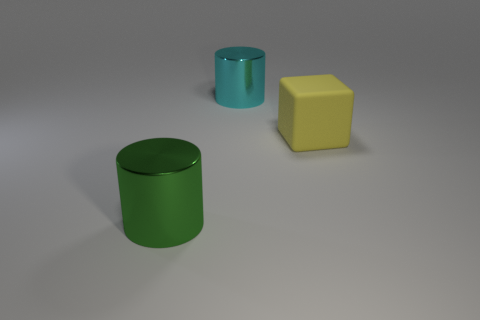There is a large metallic thing that is behind the large yellow matte block; does it have the same shape as the object that is in front of the rubber cube?
Your response must be concise. Yes. How many other things are the same material as the green cylinder?
Keep it short and to the point. 1. Do the big cylinder in front of the big yellow block and the object that is behind the yellow block have the same material?
Your answer should be compact. Yes. Is there anything else of the same color as the rubber thing?
Your response must be concise. No. What number of green metallic cylinders are there?
Your answer should be compact. 1. There is a large object that is on the right side of the green cylinder and left of the big yellow thing; what shape is it?
Your answer should be compact. Cylinder. The big metallic thing in front of the cylinder behind the large shiny thing to the left of the large cyan cylinder is what shape?
Offer a terse response. Cylinder. The big thing that is both behind the green shiny thing and in front of the large cyan thing is made of what material?
Offer a terse response. Rubber. What number of cyan cylinders have the same size as the yellow rubber block?
Your response must be concise. 1. How many rubber things are big cyan things or large yellow things?
Ensure brevity in your answer.  1. 